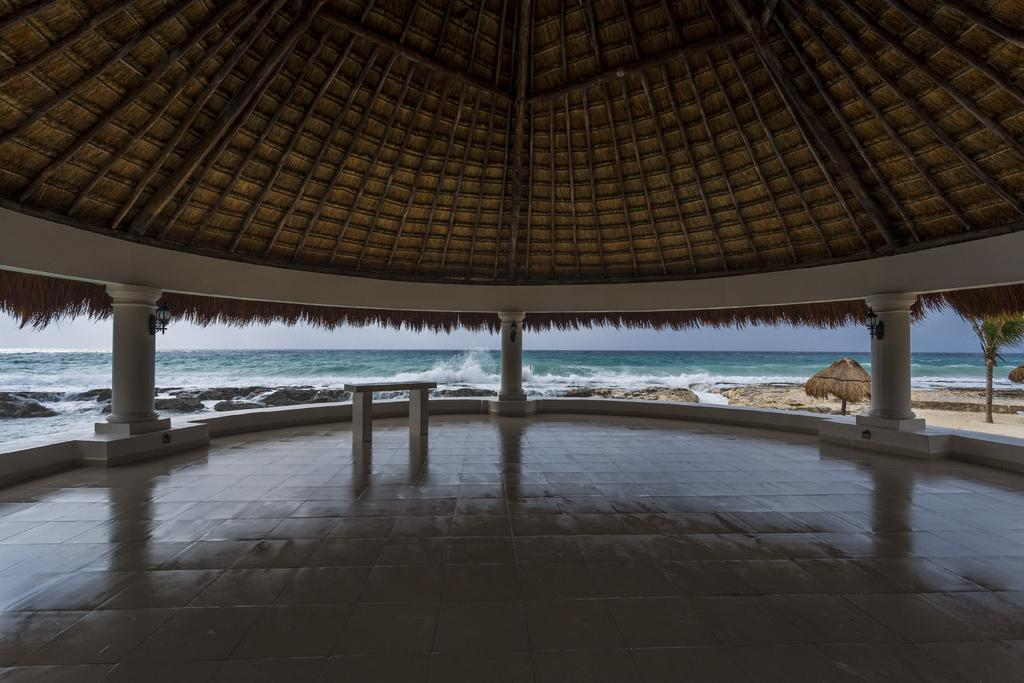What type of structure can be seen in the image? There is a shed in the image. What architectural features are present in the image? There are pillars in the image. What surface is visible in the image? There is a floor in the image. What objects can be seen on the floor? There are objects on the floor. What type of terrain is visible in the image? There is ground visible in the image. What can be seen in the background of the image? There are sheds, a tree, rocks, and water visible in the background of the image. What part of the natural environment is visible in the image? The sky is visible in the image. Where is the spoon used for stirring in the image? There is no spoon present in the image. What type of notebook is being used by the person in the image? There is no person or notebook present in the image. 